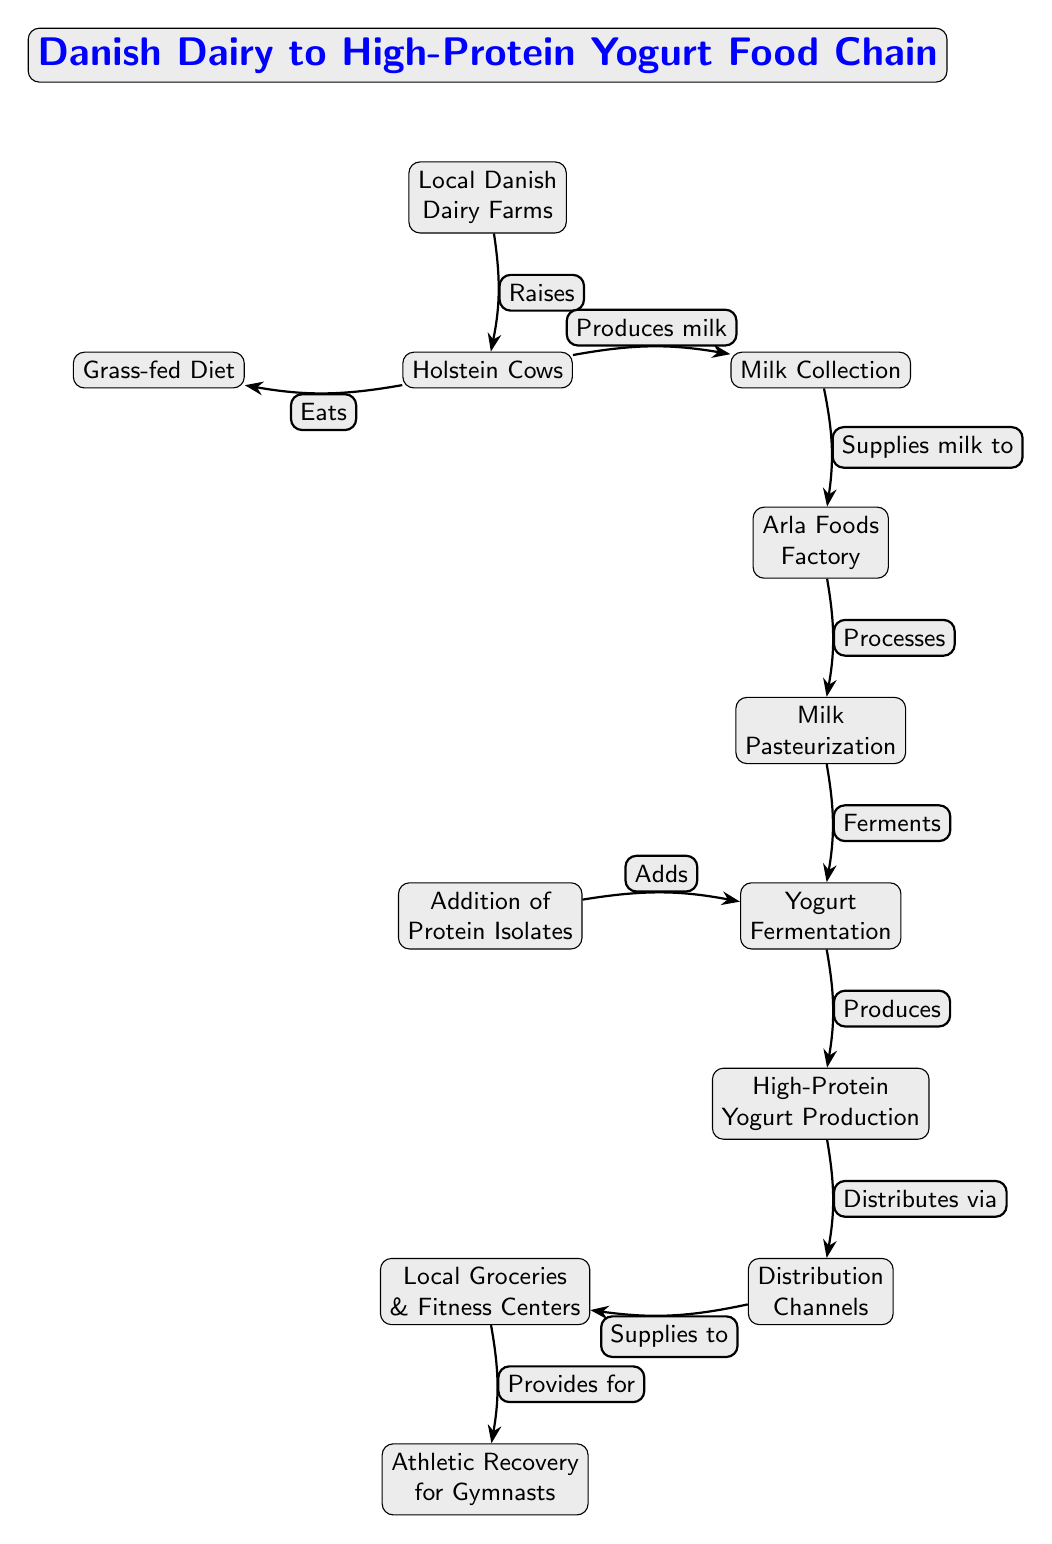What is the first node in the food chain? The food chain begins with the first node labeled "Local Danish Dairy Farms," indicating the starting point of the process.
Answer: Local Danish Dairy Farms How many nodes are there in the diagram? By counting each distinct element represented in the diagram, we find there are 12 nodes in total, from "Local Danish Dairy Farms" to "Athletic Recovery for Gymnasts."
Answer: 12 What animal is associated with the dairy farms? The diagram specifies "Holstein Cows" as the type of cow raised at the local Danish dairy farms, highlighting the specific breed linked to milk production.
Answer: Holstein Cows What process follows milk collection? After "Milk Collection," the next step is "Milk Pasteurization," detailing that collected milk undergoes pasteurization for safety and quality before further processing.
Answer: Milk Pasteurization What does the addition of protein isolates contribute to in the chain? The addition of protein isolates directly contributes to the "Yogurt Fermentation," enhancing the nutritional value of the final product aimed for athletic recovery.
Answer: Yogurt Fermentation How does high-protein yogurt reach athletic gymnasts? The high-protein yogurt produced is supplied to local groceries and fitness centers via distribution channels, which ensures availability for athletic consumption.
Answer: Local Groceries & Fitness Centers What relationship exists between local dairy farms and Holstein cows? The relationship indicated is that the local dairy farms "Raise" Holstein cows, establishing that these farms are directly responsible for the nurturing and management of this breed.
Answer: Raises What is produced at the Arla Foods Factory after pasteurization? Following pasteurization at the Arla Foods Factory, "Yogurt Fermentation" takes place, showing the sequence of production where yogurt is developed.
Answer: Yogurt Fermentation What do local groceries provide for athletes? Local groceries provide "Athletic Recovery for Gymnasts," indicating their role in supplying essential recovery nutrition for athletes through high-protein yogurt.
Answer: Athletic Recovery for Gymnasts 